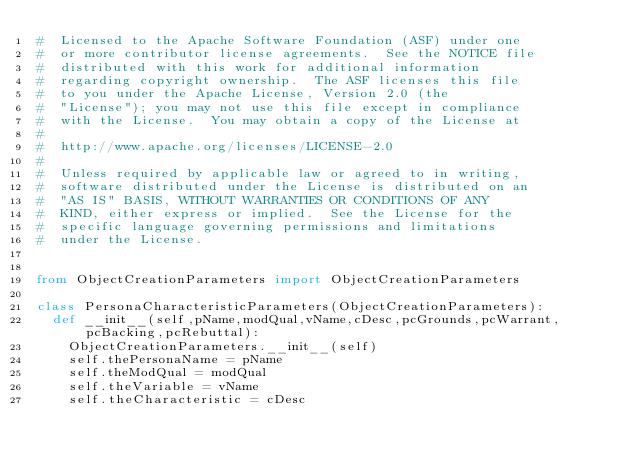<code> <loc_0><loc_0><loc_500><loc_500><_Python_>#  Licensed to the Apache Software Foundation (ASF) under one
#  or more contributor license agreements.  See the NOTICE file
#  distributed with this work for additional information
#  regarding copyright ownership.  The ASF licenses this file
#  to you under the Apache License, Version 2.0 (the
#  "License"); you may not use this file except in compliance
#  with the License.  You may obtain a copy of the License at
#
#  http://www.apache.org/licenses/LICENSE-2.0
#
#  Unless required by applicable law or agreed to in writing,
#  software distributed under the License is distributed on an
#  "AS IS" BASIS, WITHOUT WARRANTIES OR CONDITIONS OF ANY
#  KIND, either express or implied.  See the License for the
#  specific language governing permissions and limitations
#  under the License.


from ObjectCreationParameters import ObjectCreationParameters

class PersonaCharacteristicParameters(ObjectCreationParameters):
  def __init__(self,pName,modQual,vName,cDesc,pcGrounds,pcWarrant,pcBacking,pcRebuttal):
    ObjectCreationParameters.__init__(self)
    self.thePersonaName = pName
    self.theModQual = modQual
    self.theVariable = vName
    self.theCharacteristic = cDesc</code> 